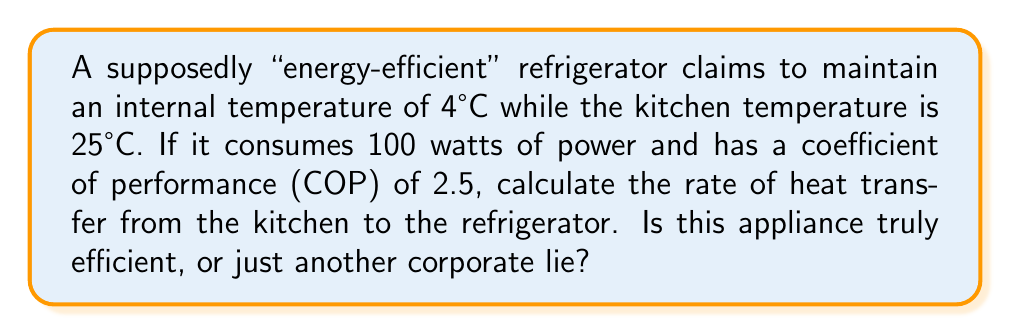Can you answer this question? Let's approach this problem step-by-step using thermodynamic principles:

1) The coefficient of performance (COP) for a refrigerator is defined as:

   $$ COP = \frac{Q_c}{W} $$

   Where $Q_c$ is the heat removed from the cold reservoir (inside the fridge) and $W$ is the work done by the refrigerator (power consumed).

2) We're given that $COP = 2.5$ and $W = 100$ watts. Let's substitute these values:

   $$ 2.5 = \frac{Q_c}{100} $$

3) Solving for $Q_c$:

   $$ Q_c = 2.5 \times 100 = 250 \text{ watts} $$

4) This means the refrigerator is removing 250 watts of heat from its interior.

5) Now, we can use the First Law of Thermodynamics. For a refrigerator:

   $$ Q_h = Q_c + W $$

   Where $Q_h$ is the heat rejected to the hot reservoir (the kitchen).

6) Substituting our known values:

   $$ Q_h = 250 + 100 = 350 \text{ watts} $$

7) This 350 watts is the rate of heat transfer from the kitchen to the refrigerator.

8) To assess efficiency, we can compare this to the Carnot COP, which is the theoretical maximum:

   $$ COP_{Carnot} = \frac{T_c}{T_h - T_c} $$

   Where $T_c$ and $T_h$ are the cold and hot temperatures in Kelvin.

9) Converting temperatures: $T_c = 4 + 273.15 = 277.15 \text{ K}$, $T_h = 25 + 273.15 = 298.15 \text{ K}$

10) Calculating Carnot COP:

    $$ COP_{Carnot} = \frac{277.15}{298.15 - 277.15} = 13.2 $$

11) The actual COP (2.5) is only about 19% of the Carnot COP, indicating significant room for improvement.
Answer: 350 watts; inefficient (only 19% of ideal efficiency) 